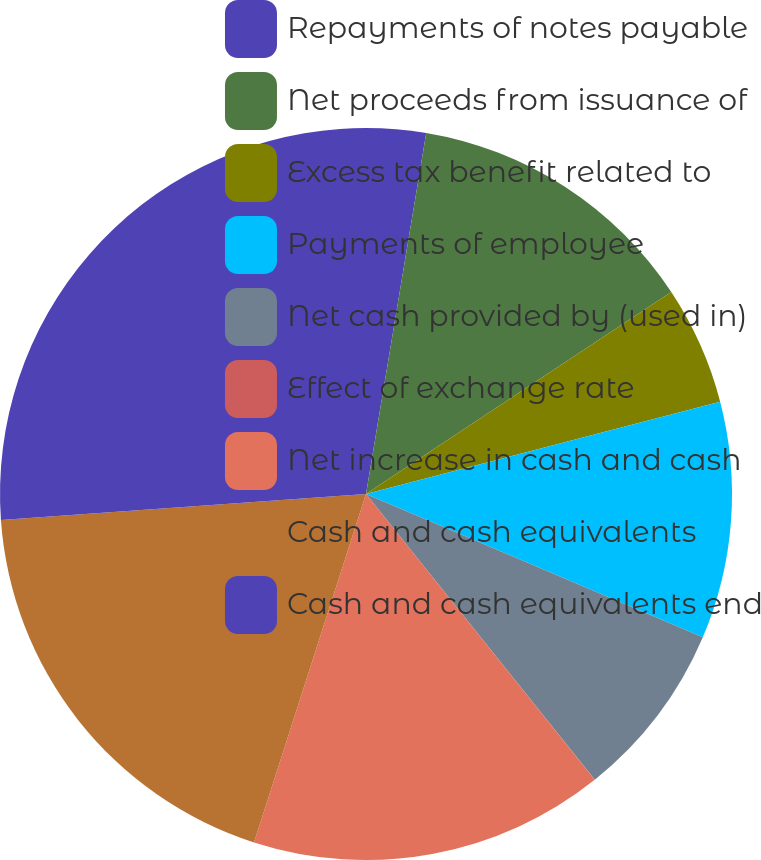Convert chart to OTSL. <chart><loc_0><loc_0><loc_500><loc_500><pie_chart><fcel>Repayments of notes payable<fcel>Net proceeds from issuance of<fcel>Excess tax benefit related to<fcel>Payments of employee<fcel>Net cash provided by (used in)<fcel>Effect of exchange rate<fcel>Net increase in cash and cash<fcel>Cash and cash equivalents<fcel>Cash and cash equivalents end<nl><fcel>2.63%<fcel>13.07%<fcel>5.24%<fcel>10.46%<fcel>7.85%<fcel>0.01%<fcel>15.69%<fcel>18.92%<fcel>26.13%<nl></chart> 